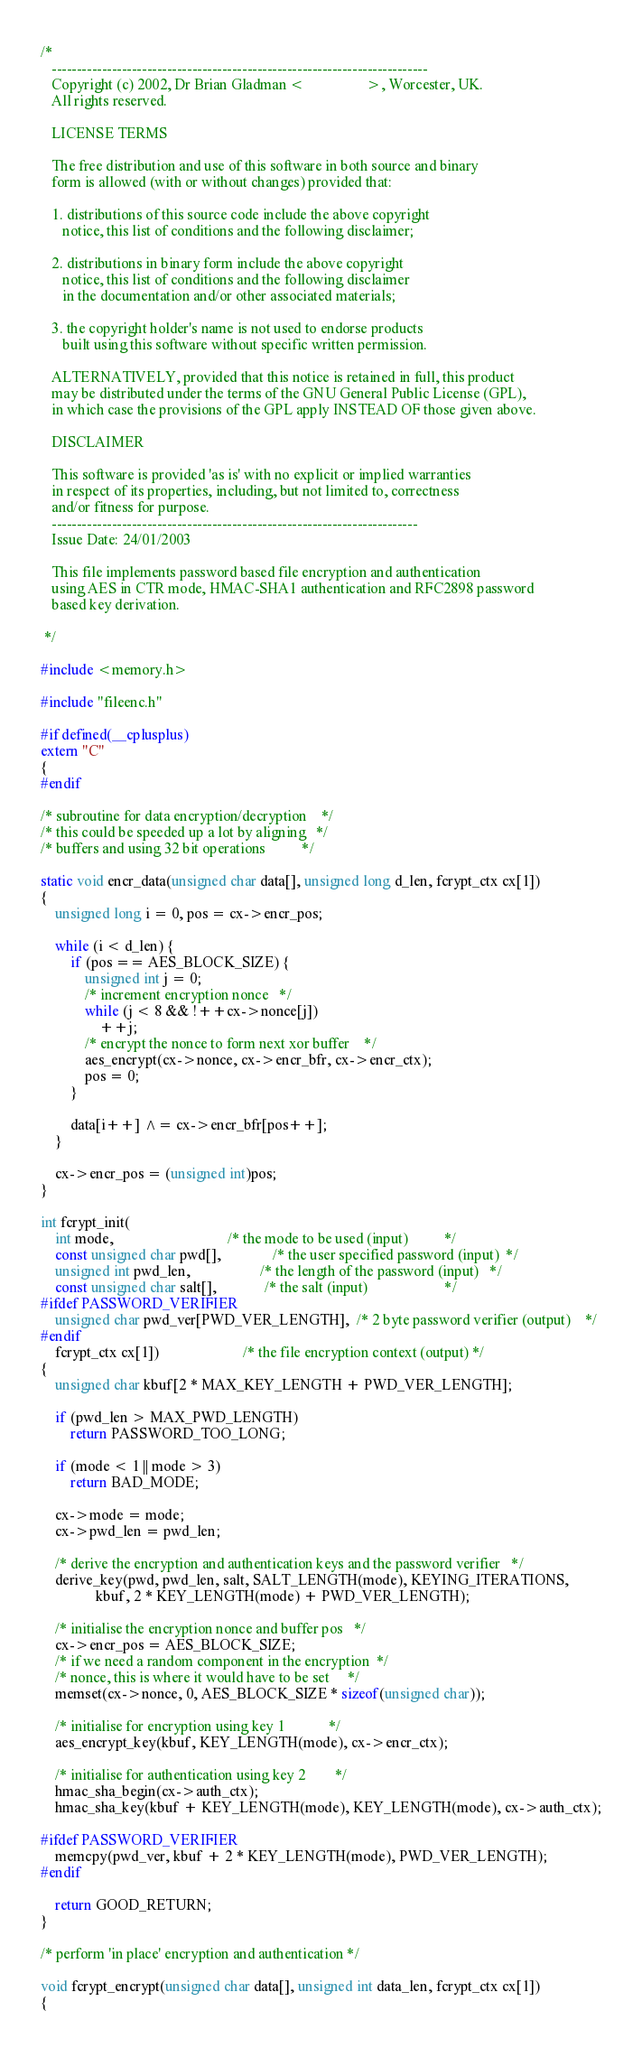Convert code to text. <code><loc_0><loc_0><loc_500><loc_500><_C_>/*
   ---------------------------------------------------------------------------
   Copyright (c) 2002, Dr Brian Gladman <                 >, Worcester, UK.
   All rights reserved.

   LICENSE TERMS

   The free distribution and use of this software in both source and binary
   form is allowed (with or without changes) provided that:

   1. distributions of this source code include the above copyright
      notice, this list of conditions and the following disclaimer;

   2. distributions in binary form include the above copyright
      notice, this list of conditions and the following disclaimer
      in the documentation and/or other associated materials;

   3. the copyright holder's name is not used to endorse products
      built using this software without specific written permission.

   ALTERNATIVELY, provided that this notice is retained in full, this product
   may be distributed under the terms of the GNU General Public License (GPL),
   in which case the provisions of the GPL apply INSTEAD OF those given above.

   DISCLAIMER

   This software is provided 'as is' with no explicit or implied warranties
   in respect of its properties, including, but not limited to, correctness
   and/or fitness for purpose.
   -------------------------------------------------------------------------
   Issue Date: 24/01/2003

   This file implements password based file encryption and authentication
   using AES in CTR mode, HMAC-SHA1 authentication and RFC2898 password
   based key derivation.

 */

#include <memory.h>

#include "fileenc.h"

#if defined(__cplusplus)
extern "C"
{
#endif

/* subroutine for data encryption/decryption    */
/* this could be speeded up a lot by aligning   */
/* buffers and using 32 bit operations          */

static void encr_data(unsigned char data[], unsigned long d_len, fcrypt_ctx cx[1])
{
    unsigned long i = 0, pos = cx->encr_pos;

    while (i < d_len) {
        if (pos == AES_BLOCK_SIZE) {
            unsigned int j = 0;
            /* increment encryption nonce   */
            while (j < 8 && !++cx->nonce[j])
                ++j;
            /* encrypt the nonce to form next xor buffer    */
            aes_encrypt(cx->nonce, cx->encr_bfr, cx->encr_ctx);
            pos = 0;
        }

        data[i++] ^= cx->encr_bfr[pos++];
    }

    cx->encr_pos = (unsigned int)pos;
}

int fcrypt_init(
    int mode,                               /* the mode to be used (input)          */
    const unsigned char pwd[],              /* the user specified password (input)  */
    unsigned int pwd_len,                   /* the length of the password (input)   */
    const unsigned char salt[],             /* the salt (input)                     */
#ifdef PASSWORD_VERIFIER
    unsigned char pwd_ver[PWD_VER_LENGTH],  /* 2 byte password verifier (output)    */
#endif
    fcrypt_ctx cx[1])                       /* the file encryption context (output) */
{
    unsigned char kbuf[2 * MAX_KEY_LENGTH + PWD_VER_LENGTH];

    if (pwd_len > MAX_PWD_LENGTH)
        return PASSWORD_TOO_LONG;

    if (mode < 1 || mode > 3)
        return BAD_MODE;

    cx->mode = mode;
    cx->pwd_len = pwd_len;

    /* derive the encryption and authentication keys and the password verifier   */
    derive_key(pwd, pwd_len, salt, SALT_LENGTH(mode), KEYING_ITERATIONS,
               kbuf, 2 * KEY_LENGTH(mode) + PWD_VER_LENGTH);

    /* initialise the encryption nonce and buffer pos   */
    cx->encr_pos = AES_BLOCK_SIZE;
    /* if we need a random component in the encryption  */
    /* nonce, this is where it would have to be set     */
    memset(cx->nonce, 0, AES_BLOCK_SIZE * sizeof(unsigned char));

    /* initialise for encryption using key 1            */
    aes_encrypt_key(kbuf, KEY_LENGTH(mode), cx->encr_ctx);

    /* initialise for authentication using key 2        */
    hmac_sha_begin(cx->auth_ctx);
    hmac_sha_key(kbuf + KEY_LENGTH(mode), KEY_LENGTH(mode), cx->auth_ctx);

#ifdef PASSWORD_VERIFIER
    memcpy(pwd_ver, kbuf + 2 * KEY_LENGTH(mode), PWD_VER_LENGTH);
#endif

    return GOOD_RETURN;
}

/* perform 'in place' encryption and authentication */

void fcrypt_encrypt(unsigned char data[], unsigned int data_len, fcrypt_ctx cx[1])
{</code> 